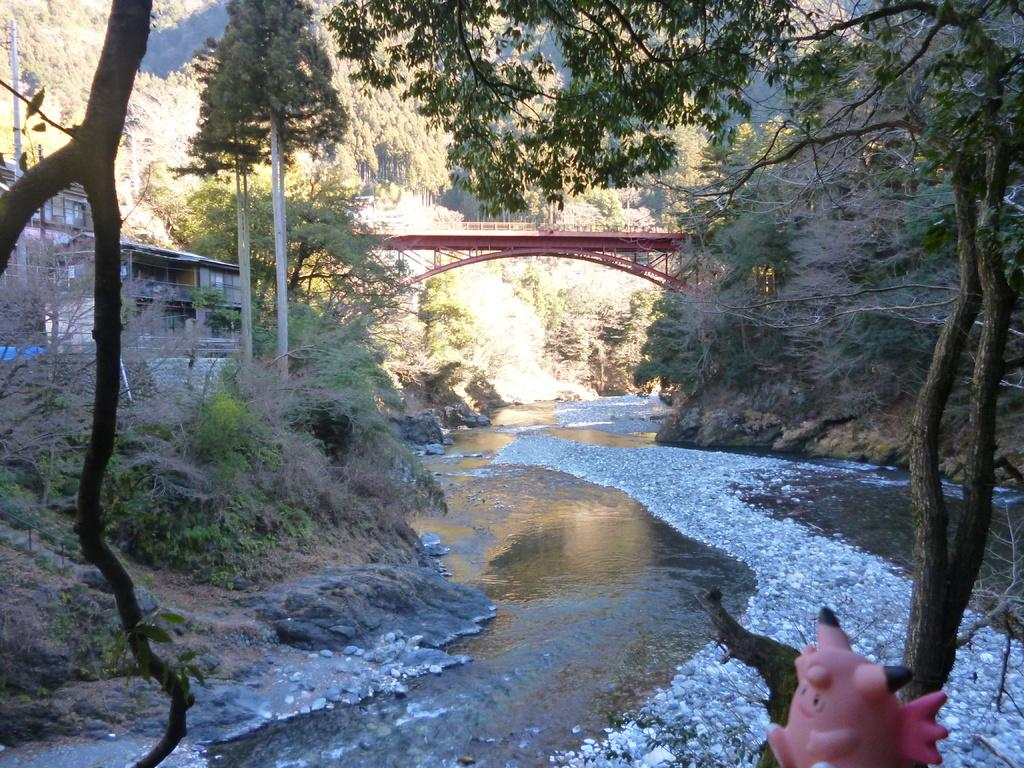What object is placed on a tree in the image? There is a toy placed on a tree in the image. What natural element can be seen in the image? Water is visible in the image. What type of geological formation is present in the image? Rocks are present in the image. What man-made structures can be seen in the image? There are buildings and a bridge in the image. What type of vegetation is present in the image? Trees are present in the image. What type of landscape feature is visible in the background of the image? Hills are visible in the background of the image. What type of division is taking place in the image? There is no division taking place in the image. Can you see any bombs in the image? There are no bombs present in the image. What company is responsible for the construction of the bridge in the image? The image does not provide information about the company responsible for the construction of the bridge. 